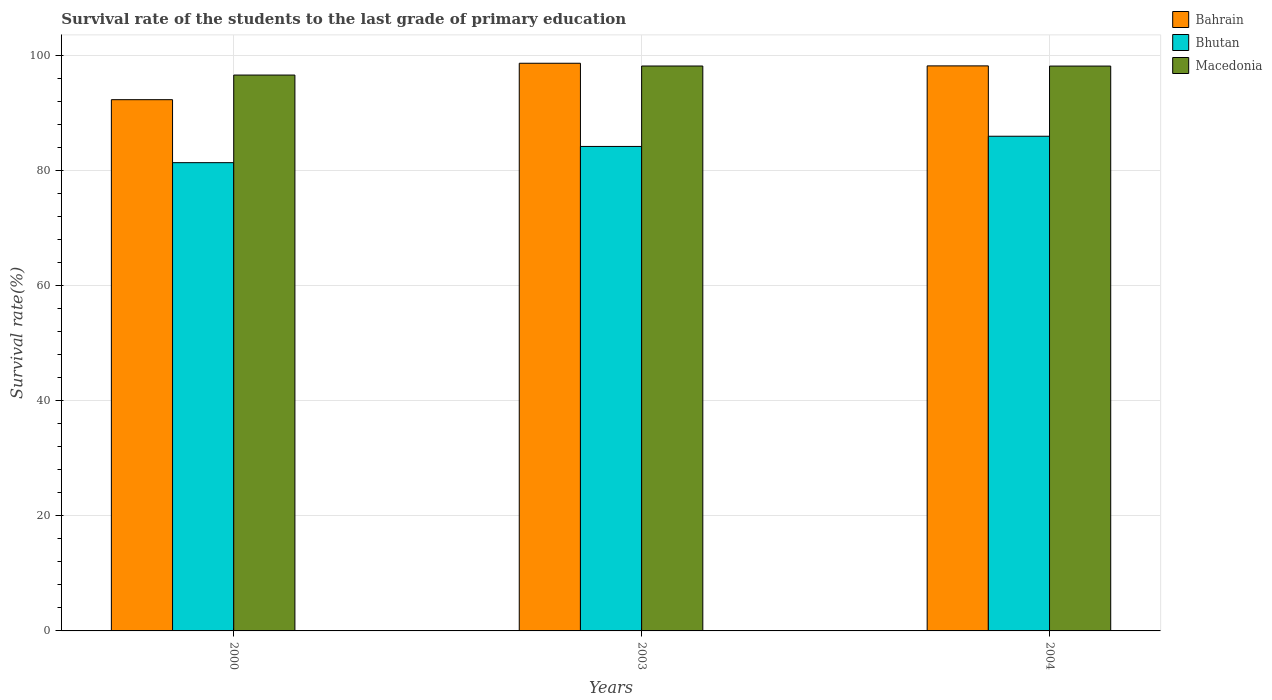How many groups of bars are there?
Your response must be concise. 3. Are the number of bars on each tick of the X-axis equal?
Provide a succinct answer. Yes. How many bars are there on the 3rd tick from the left?
Make the answer very short. 3. What is the survival rate of the students in Bahrain in 2004?
Keep it short and to the point. 98.21. Across all years, what is the maximum survival rate of the students in Bhutan?
Offer a terse response. 85.99. Across all years, what is the minimum survival rate of the students in Bahrain?
Your answer should be compact. 92.34. In which year was the survival rate of the students in Bhutan minimum?
Your answer should be very brief. 2000. What is the total survival rate of the students in Bhutan in the graph?
Ensure brevity in your answer.  251.59. What is the difference between the survival rate of the students in Bahrain in 2000 and that in 2004?
Your answer should be compact. -5.87. What is the difference between the survival rate of the students in Bhutan in 2000 and the survival rate of the students in Macedonia in 2003?
Your answer should be compact. -16.8. What is the average survival rate of the students in Bahrain per year?
Your answer should be compact. 96.41. In the year 2000, what is the difference between the survival rate of the students in Macedonia and survival rate of the students in Bahrain?
Make the answer very short. 4.28. In how many years, is the survival rate of the students in Macedonia greater than 40 %?
Provide a short and direct response. 3. What is the ratio of the survival rate of the students in Macedonia in 2000 to that in 2003?
Offer a very short reply. 0.98. Is the survival rate of the students in Bahrain in 2003 less than that in 2004?
Offer a terse response. No. Is the difference between the survival rate of the students in Macedonia in 2000 and 2003 greater than the difference between the survival rate of the students in Bahrain in 2000 and 2003?
Give a very brief answer. Yes. What is the difference between the highest and the second highest survival rate of the students in Bhutan?
Provide a short and direct response. 1.77. What is the difference between the highest and the lowest survival rate of the students in Bahrain?
Give a very brief answer. 6.33. Is the sum of the survival rate of the students in Macedonia in 2003 and 2004 greater than the maximum survival rate of the students in Bahrain across all years?
Offer a terse response. Yes. What does the 2nd bar from the left in 2000 represents?
Your answer should be very brief. Bhutan. What does the 1st bar from the right in 2000 represents?
Your answer should be very brief. Macedonia. How many bars are there?
Provide a short and direct response. 9. Are the values on the major ticks of Y-axis written in scientific E-notation?
Your response must be concise. No. Does the graph contain any zero values?
Ensure brevity in your answer.  No. What is the title of the graph?
Your answer should be very brief. Survival rate of the students to the last grade of primary education. Does "Guam" appear as one of the legend labels in the graph?
Give a very brief answer. No. What is the label or title of the X-axis?
Your answer should be compact. Years. What is the label or title of the Y-axis?
Your answer should be compact. Survival rate(%). What is the Survival rate(%) of Bahrain in 2000?
Your response must be concise. 92.34. What is the Survival rate(%) of Bhutan in 2000?
Your response must be concise. 81.39. What is the Survival rate(%) of Macedonia in 2000?
Offer a terse response. 96.62. What is the Survival rate(%) in Bahrain in 2003?
Your answer should be very brief. 98.67. What is the Survival rate(%) of Bhutan in 2003?
Give a very brief answer. 84.21. What is the Survival rate(%) of Macedonia in 2003?
Make the answer very short. 98.19. What is the Survival rate(%) in Bahrain in 2004?
Your answer should be compact. 98.21. What is the Survival rate(%) of Bhutan in 2004?
Your response must be concise. 85.99. What is the Survival rate(%) in Macedonia in 2004?
Ensure brevity in your answer.  98.18. Across all years, what is the maximum Survival rate(%) of Bahrain?
Offer a very short reply. 98.67. Across all years, what is the maximum Survival rate(%) of Bhutan?
Make the answer very short. 85.99. Across all years, what is the maximum Survival rate(%) in Macedonia?
Make the answer very short. 98.19. Across all years, what is the minimum Survival rate(%) of Bahrain?
Provide a short and direct response. 92.34. Across all years, what is the minimum Survival rate(%) in Bhutan?
Provide a succinct answer. 81.39. Across all years, what is the minimum Survival rate(%) in Macedonia?
Keep it short and to the point. 96.62. What is the total Survival rate(%) in Bahrain in the graph?
Offer a very short reply. 289.22. What is the total Survival rate(%) in Bhutan in the graph?
Offer a terse response. 251.59. What is the total Survival rate(%) of Macedonia in the graph?
Offer a very short reply. 292.99. What is the difference between the Survival rate(%) in Bahrain in 2000 and that in 2003?
Give a very brief answer. -6.33. What is the difference between the Survival rate(%) of Bhutan in 2000 and that in 2003?
Your response must be concise. -2.82. What is the difference between the Survival rate(%) in Macedonia in 2000 and that in 2003?
Your answer should be very brief. -1.57. What is the difference between the Survival rate(%) in Bahrain in 2000 and that in 2004?
Give a very brief answer. -5.87. What is the difference between the Survival rate(%) in Bhutan in 2000 and that in 2004?
Offer a terse response. -4.59. What is the difference between the Survival rate(%) of Macedonia in 2000 and that in 2004?
Offer a terse response. -1.56. What is the difference between the Survival rate(%) in Bahrain in 2003 and that in 2004?
Provide a succinct answer. 0.46. What is the difference between the Survival rate(%) of Bhutan in 2003 and that in 2004?
Your response must be concise. -1.77. What is the difference between the Survival rate(%) of Macedonia in 2003 and that in 2004?
Offer a terse response. 0.01. What is the difference between the Survival rate(%) in Bahrain in 2000 and the Survival rate(%) in Bhutan in 2003?
Give a very brief answer. 8.13. What is the difference between the Survival rate(%) of Bahrain in 2000 and the Survival rate(%) of Macedonia in 2003?
Give a very brief answer. -5.85. What is the difference between the Survival rate(%) of Bhutan in 2000 and the Survival rate(%) of Macedonia in 2003?
Offer a terse response. -16.8. What is the difference between the Survival rate(%) in Bahrain in 2000 and the Survival rate(%) in Bhutan in 2004?
Offer a terse response. 6.35. What is the difference between the Survival rate(%) in Bahrain in 2000 and the Survival rate(%) in Macedonia in 2004?
Provide a short and direct response. -5.84. What is the difference between the Survival rate(%) in Bhutan in 2000 and the Survival rate(%) in Macedonia in 2004?
Provide a succinct answer. -16.79. What is the difference between the Survival rate(%) in Bahrain in 2003 and the Survival rate(%) in Bhutan in 2004?
Offer a terse response. 12.69. What is the difference between the Survival rate(%) in Bahrain in 2003 and the Survival rate(%) in Macedonia in 2004?
Offer a terse response. 0.49. What is the difference between the Survival rate(%) in Bhutan in 2003 and the Survival rate(%) in Macedonia in 2004?
Give a very brief answer. -13.97. What is the average Survival rate(%) in Bahrain per year?
Keep it short and to the point. 96.41. What is the average Survival rate(%) in Bhutan per year?
Your answer should be very brief. 83.86. What is the average Survival rate(%) in Macedonia per year?
Ensure brevity in your answer.  97.67. In the year 2000, what is the difference between the Survival rate(%) in Bahrain and Survival rate(%) in Bhutan?
Provide a short and direct response. 10.95. In the year 2000, what is the difference between the Survival rate(%) of Bahrain and Survival rate(%) of Macedonia?
Give a very brief answer. -4.28. In the year 2000, what is the difference between the Survival rate(%) in Bhutan and Survival rate(%) in Macedonia?
Keep it short and to the point. -15.23. In the year 2003, what is the difference between the Survival rate(%) of Bahrain and Survival rate(%) of Bhutan?
Keep it short and to the point. 14.46. In the year 2003, what is the difference between the Survival rate(%) of Bahrain and Survival rate(%) of Macedonia?
Your answer should be compact. 0.48. In the year 2003, what is the difference between the Survival rate(%) of Bhutan and Survival rate(%) of Macedonia?
Offer a very short reply. -13.98. In the year 2004, what is the difference between the Survival rate(%) of Bahrain and Survival rate(%) of Bhutan?
Your answer should be compact. 12.23. In the year 2004, what is the difference between the Survival rate(%) in Bahrain and Survival rate(%) in Macedonia?
Give a very brief answer. 0.03. In the year 2004, what is the difference between the Survival rate(%) in Bhutan and Survival rate(%) in Macedonia?
Offer a terse response. -12.2. What is the ratio of the Survival rate(%) in Bahrain in 2000 to that in 2003?
Make the answer very short. 0.94. What is the ratio of the Survival rate(%) in Bhutan in 2000 to that in 2003?
Offer a very short reply. 0.97. What is the ratio of the Survival rate(%) in Bahrain in 2000 to that in 2004?
Provide a short and direct response. 0.94. What is the ratio of the Survival rate(%) of Bhutan in 2000 to that in 2004?
Offer a terse response. 0.95. What is the ratio of the Survival rate(%) in Macedonia in 2000 to that in 2004?
Your answer should be compact. 0.98. What is the ratio of the Survival rate(%) in Bhutan in 2003 to that in 2004?
Your answer should be compact. 0.98. What is the difference between the highest and the second highest Survival rate(%) of Bahrain?
Make the answer very short. 0.46. What is the difference between the highest and the second highest Survival rate(%) in Bhutan?
Provide a succinct answer. 1.77. What is the difference between the highest and the second highest Survival rate(%) of Macedonia?
Offer a very short reply. 0.01. What is the difference between the highest and the lowest Survival rate(%) in Bahrain?
Your response must be concise. 6.33. What is the difference between the highest and the lowest Survival rate(%) of Bhutan?
Offer a terse response. 4.59. What is the difference between the highest and the lowest Survival rate(%) in Macedonia?
Your answer should be very brief. 1.57. 